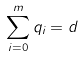Convert formula to latex. <formula><loc_0><loc_0><loc_500><loc_500>\sum _ { i = 0 } ^ { m } q _ { i } = d</formula> 